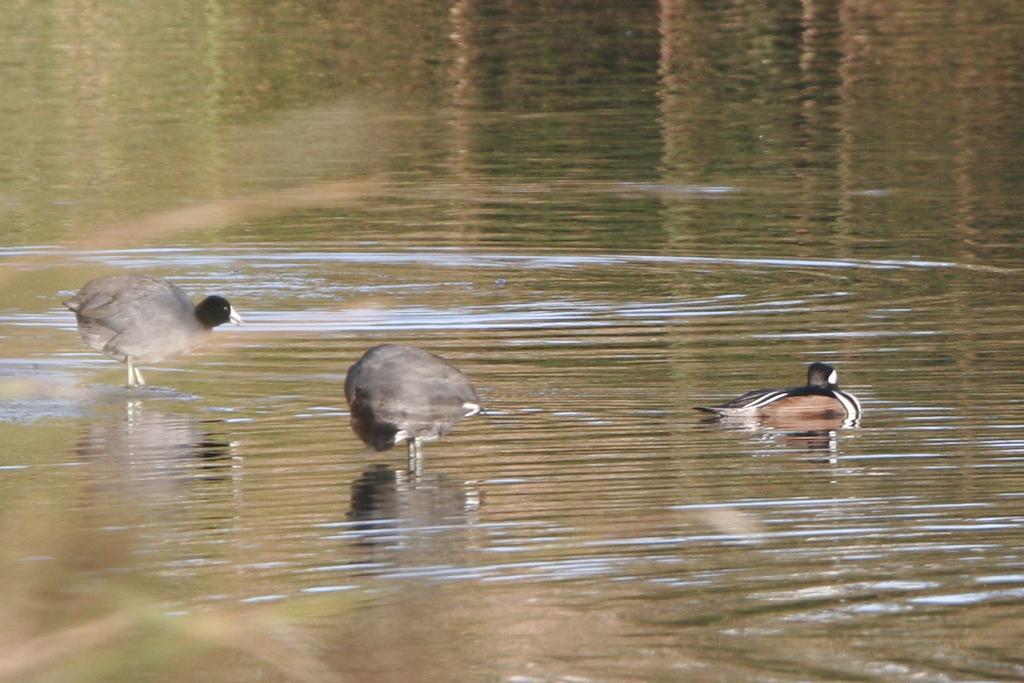Describe this image in one or two sentences. In this image we can see three birds on the water. 